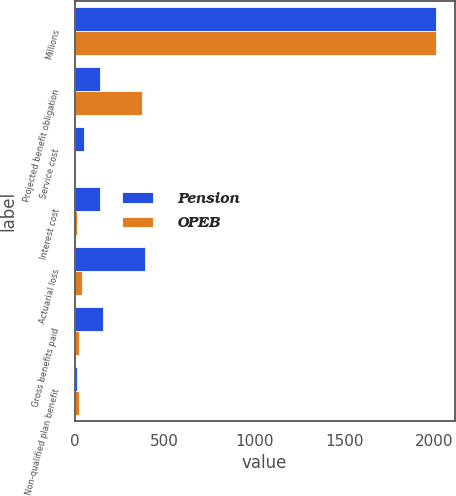<chart> <loc_0><loc_0><loc_500><loc_500><stacked_bar_chart><ecel><fcel>Millions<fcel>Projected benefit obligation<fcel>Service cost<fcel>Interest cost<fcel>Actuarial loss<fcel>Gross benefits paid<fcel>Non-qualified plan benefit<nl><fcel>Pension<fcel>2012<fcel>141<fcel>54<fcel>141<fcel>391<fcel>160<fcel>15<nl><fcel>OPEB<fcel>2012<fcel>372<fcel>3<fcel>15<fcel>42<fcel>24<fcel>24<nl></chart> 